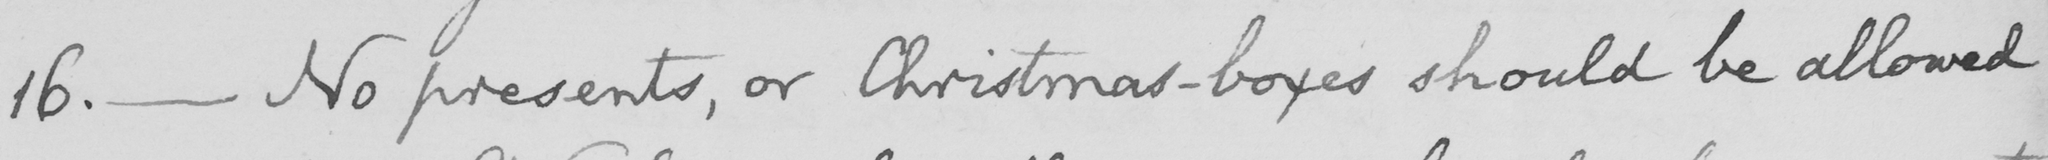Please provide the text content of this handwritten line. 16 .  _  No presents , or Christmas-boxes should be allowed 